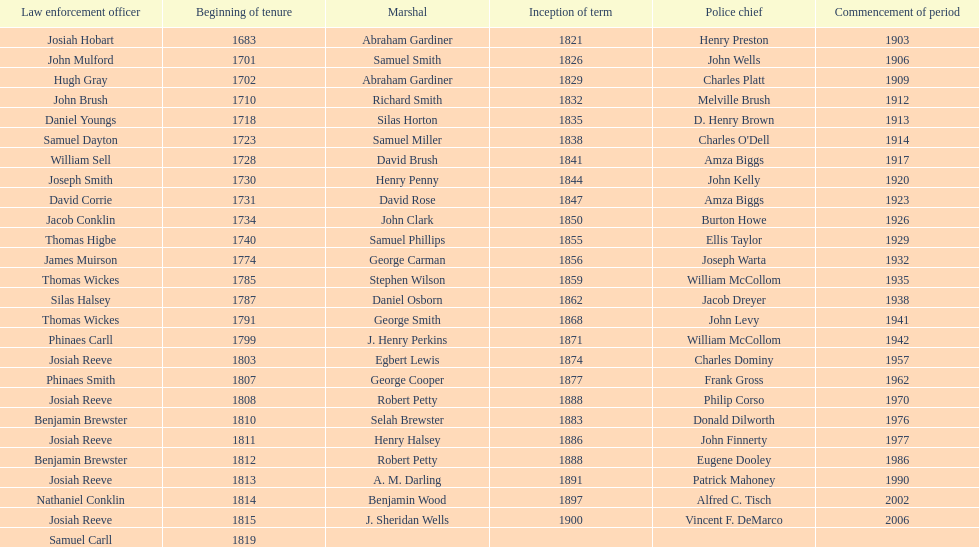Which sheriff came before thomas wickes? James Muirson. 